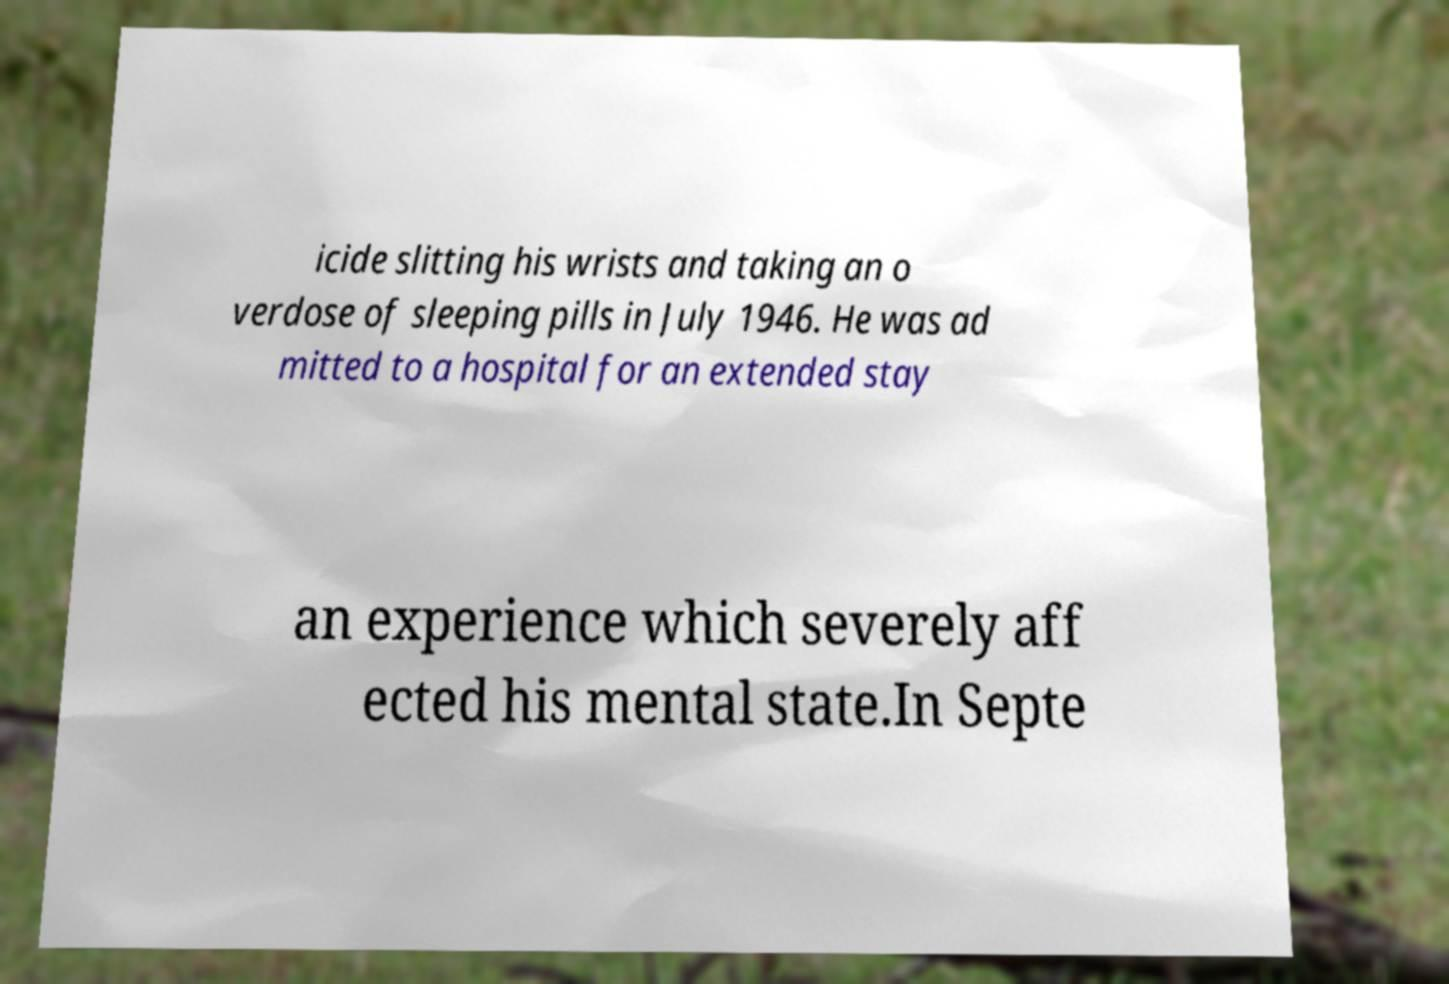There's text embedded in this image that I need extracted. Can you transcribe it verbatim? icide slitting his wrists and taking an o verdose of sleeping pills in July 1946. He was ad mitted to a hospital for an extended stay an experience which severely aff ected his mental state.In Septe 